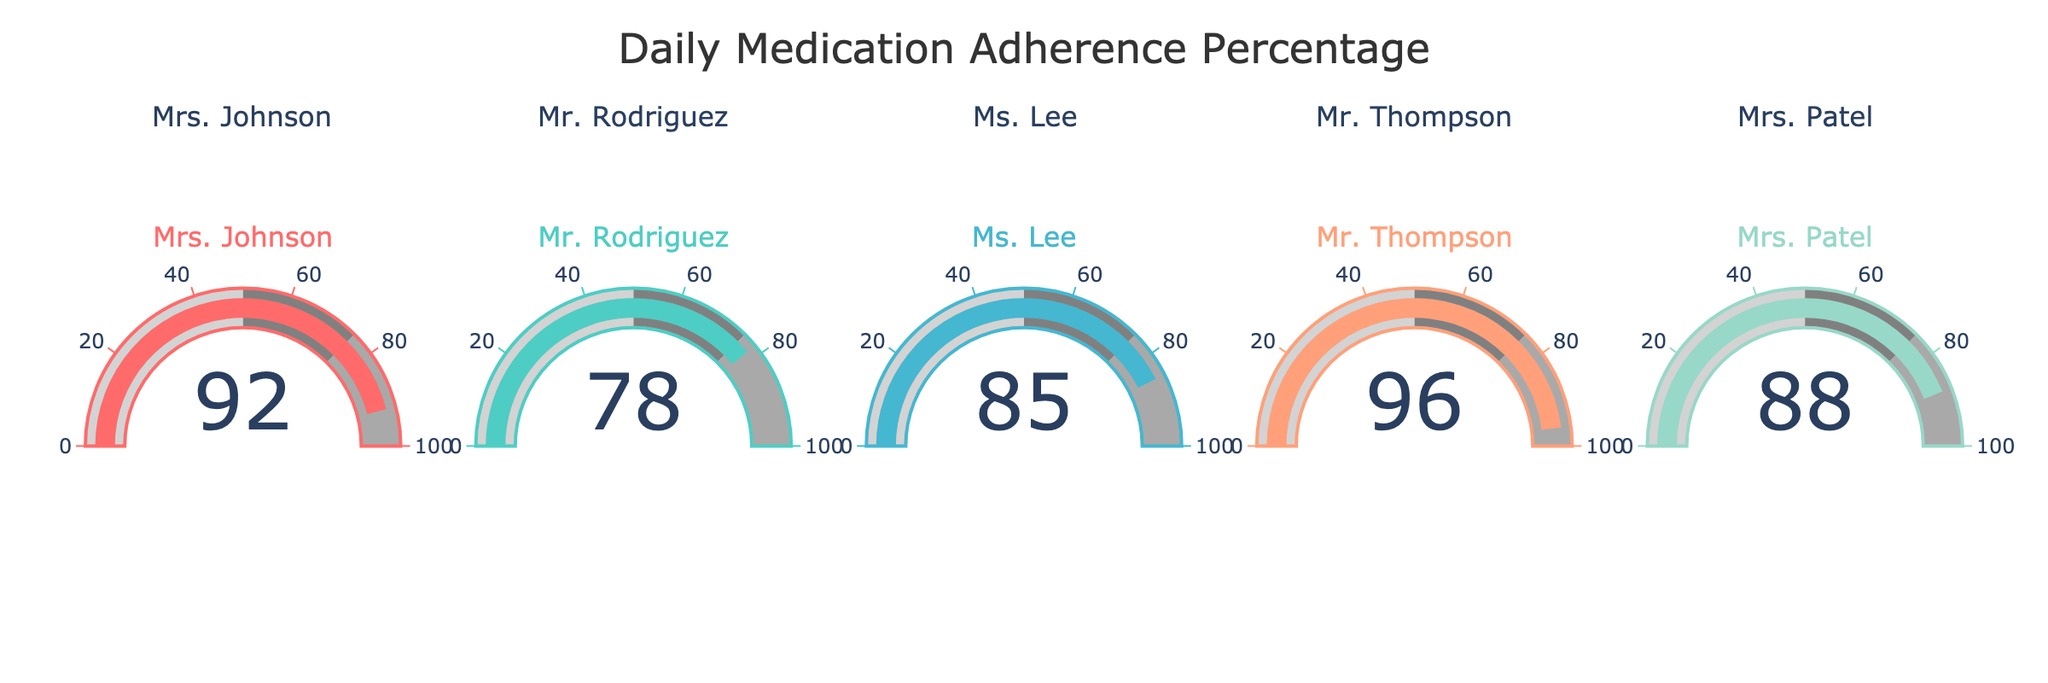What's the title of the figure? The title of the figure is given at the top of the chart. We can read it directly as "Daily Medication Adherence Percentage".
Answer: Daily Medication Adherence Percentage Which patient has the highest medication adherence percentage? By examining the gauge charts, we can see that the patient with the highest medication adherence percentage is Mr. Thompson, with a value of 96.
Answer: Mr. Thompson Which patient has the lowest medication adherence percentage? From the gauge charts, we observe that the patient with the lowest medication adherence percentage is Mr. Rodriguez, with a value of 78.
Answer: Mr. Rodriguez What is the range of adherence percentages shown in the figure? The adherence percentages range from the lowest value of 78% (Mr. Rodriguez) to the highest value of 96% (Mr. Thompson).
Answer: 78-96 What's the average medication adherence percentage across all patients? The adherence percentages are 92, 78, 85, 96, and 88. Summing these values gives 439. Dividing by the total number of patients (5) results in an average of 439 / 5 = 87.8.
Answer: 87.8 How many patients have an adherence percentage above 80? From the gauges, we can see that Mrs. Johnson, Ms. Lee, Mr. Thompson, and Mrs. Patel have adherence percentages above 80%. Counting these patients, we get a total of 4.
Answer: 4 Is anyone's medication adherence percentage below 75? By looking at the gauge charts, we see that none of the patients have a medication adherence percentage below 75.
Answer: No What is the difference in adherence percentage between the highest and lowest patients? The highest adherence percentage is 96 (Mr. Thompson) and the lowest is 78 (Mr. Rodriguez). The difference is computed as 96 - 78 = 18.
Answer: 18 Which patients have an adherence percentage that falls within the 75 to 90 range? By identifying the patients whose adherence percentages fall within 75 to 90, we find that Mr. Rodriguez (78), Ms. Lee (85), and Mrs. Patel (88) fit this range.
Answer: Mr. Rodriguez, Ms. Lee, Mrs. Patel What is the median adherence percentage of the patients? To find the median, we arrange the values in ascending order: 78, 85, 88, 92, 96. The median is the middle value, which in this case is 88.
Answer: 88 